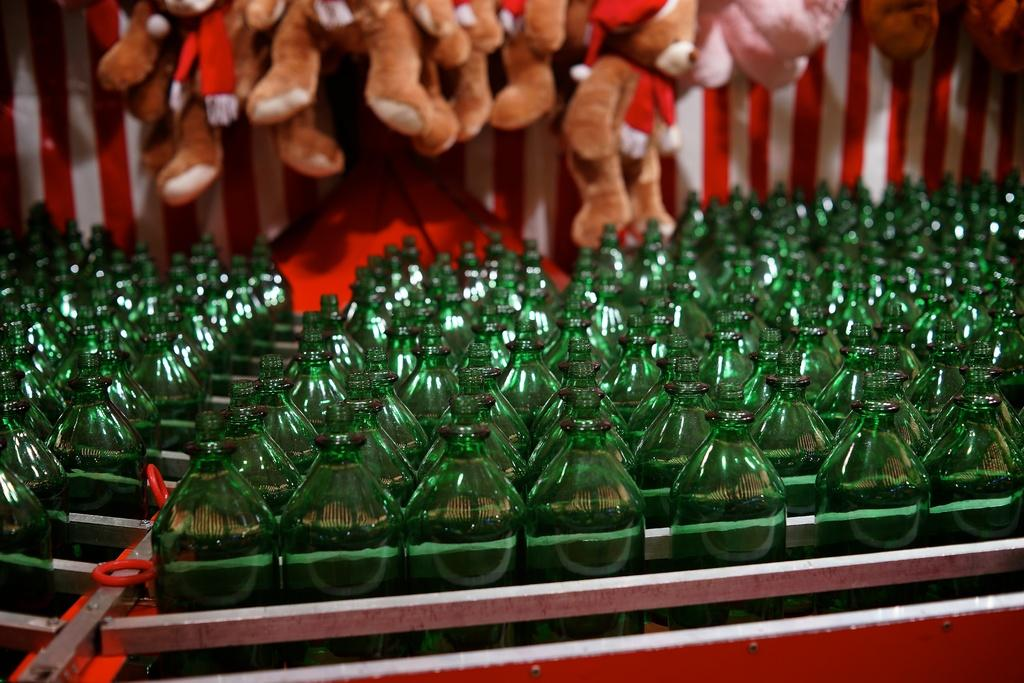What is contained in the case that is visible in the image? There is a case of bottles in the image. What else can be seen in the background of the image? There are toys visible in the background of the image. What type of quartz can be seen in the image? There is no quartz present in the image. What kind of oil is being used by the toys in the image? There is no oil or indication of any toys being used in the image; it only shows a case of bottles and toys in the background. 